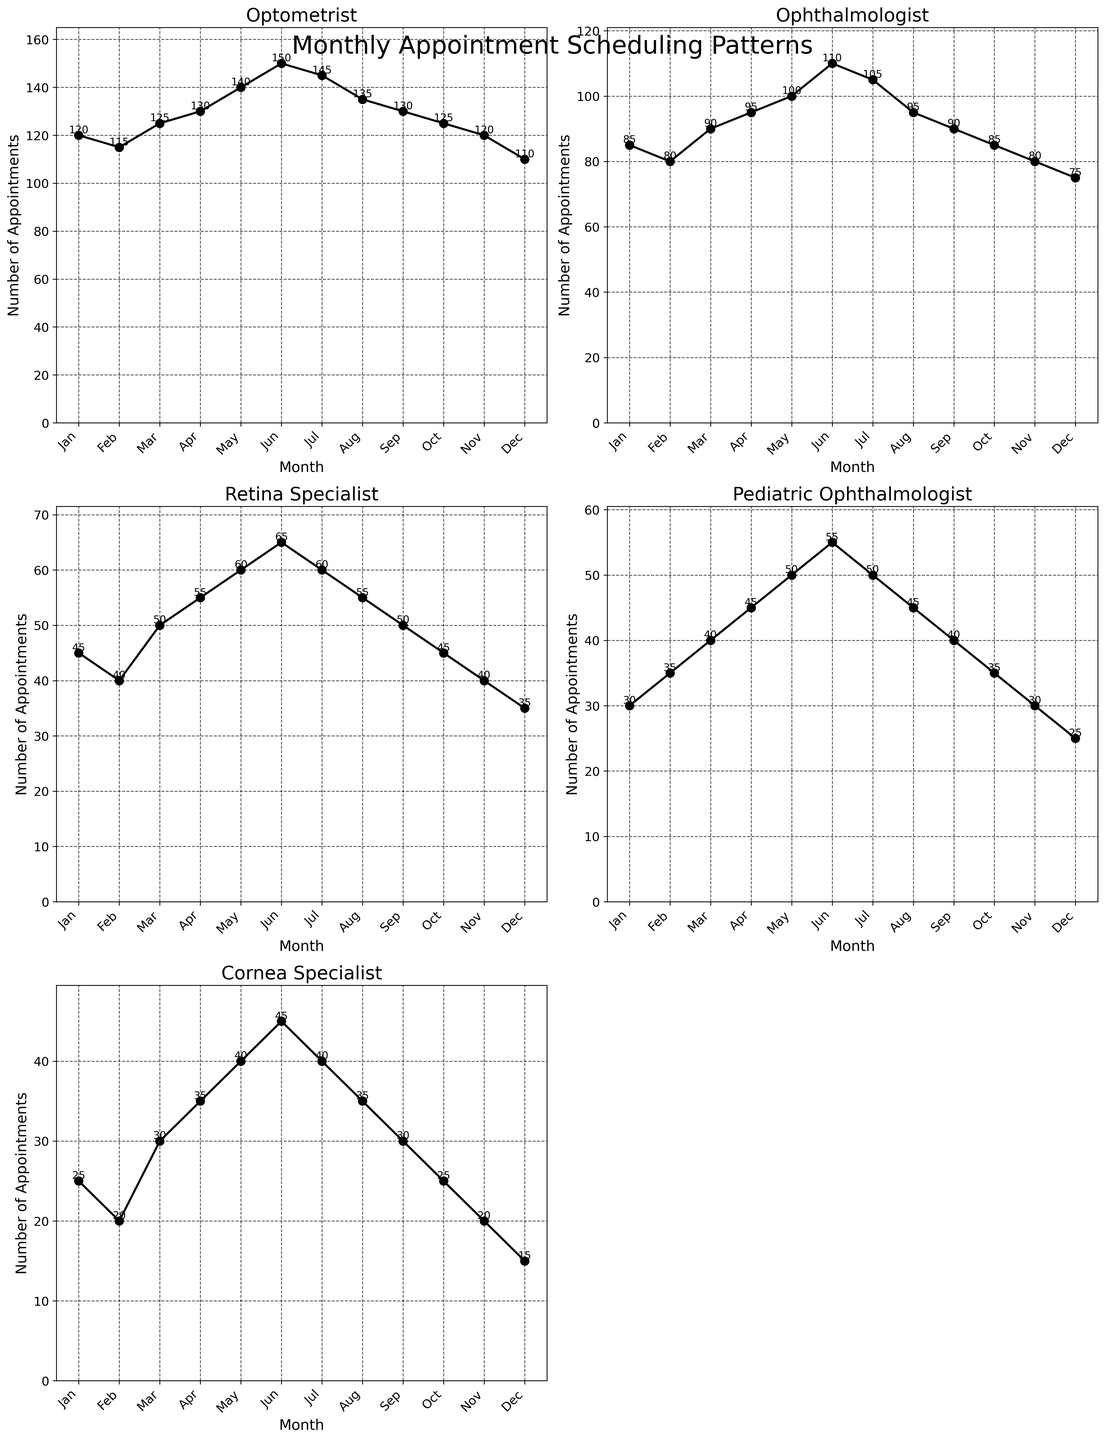Which specialist had the highest number of appointments in June? Look at the plot for each specialist and find the one with the highest point in June. The Optometrist had 150 appointments, which is the highest.
Answer: Optometrist Which specialist had the lowest number of appointments in December? Look at each subplot in December and identify the lowest value. The Cornea Specialist had 15 appointments, which is the lowest.
Answer: Cornea Specialist What is the average number of appointments made with the Cornea Specialist over the entire year? Add up the monthly values for the Cornea Specialist and then divide by 12. (25 + 20 + 30 + 35 + 40 + 45 + 40 + 35 + 30 + 25 + 20 + 15) / 12 = 30.42
Answer: 30.42 Which two specialists had the closest number of appointments in July? Compare the values for all specialists in July. The Pediatric Ophthalmologist and Cornea Specialist had 50 and 40 appointments, respectively. They differ by 10 appointments, which is the smallest difference among all comparisons.
Answer: Pediatric Ophthalmologist and Cornea Specialist What is the total number of appointments across all specialists in March? Sum the values for all specialists in March. 125 (Optometrist) + 90 (Ophthalmologist) + 50 (Retina Specialist) + 40 (Pediatric Ophthalmologist) + 30 (Cornea Specialist) = 335
Answer: 335 How did the number of appointments for the Retina Specialist change from January to June? Subtract the number of appointments in January from the number of appointments in June for the Retina Specialist. 65 (June) - 45 (January) = 20
Answer: Increased by 20 Which month shows the largest drop in the number of appointments for the Optometrist compared to the previous month? Examine the month-to-month changes for the Optometrist and identify the largest drop. The largest drop is from June to July, where appointments decreased from 150 to 145, a drop of 5.
Answer: June to July What is the total number of appointments for the Pediatric Ophthalmologist in the first half of the year? Sum the values from January to June for the Pediatric Ophthalmologist. 30 (Jan) + 35 (Feb) + 40 (Mar) + 45 (Apr) + 50 (May) + 55 (Jun) = 255
Answer: 255 